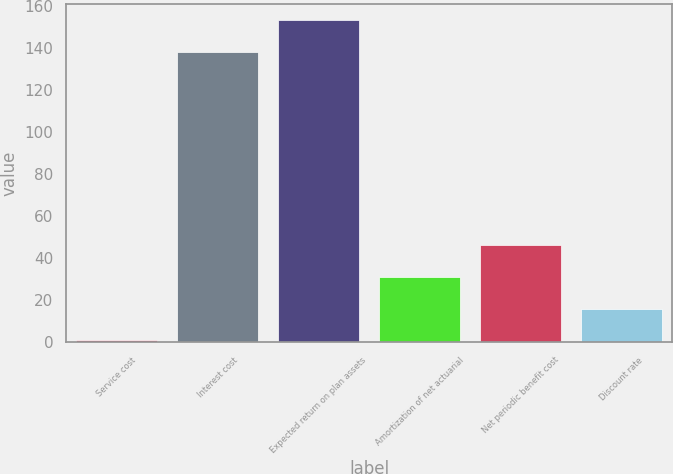Convert chart. <chart><loc_0><loc_0><loc_500><loc_500><bar_chart><fcel>Service cost<fcel>Interest cost<fcel>Expected return on plan assets<fcel>Amortization of net actuarial<fcel>Net periodic benefit cost<fcel>Discount rate<nl><fcel>1<fcel>138<fcel>153.1<fcel>31.2<fcel>46.3<fcel>16.1<nl></chart> 